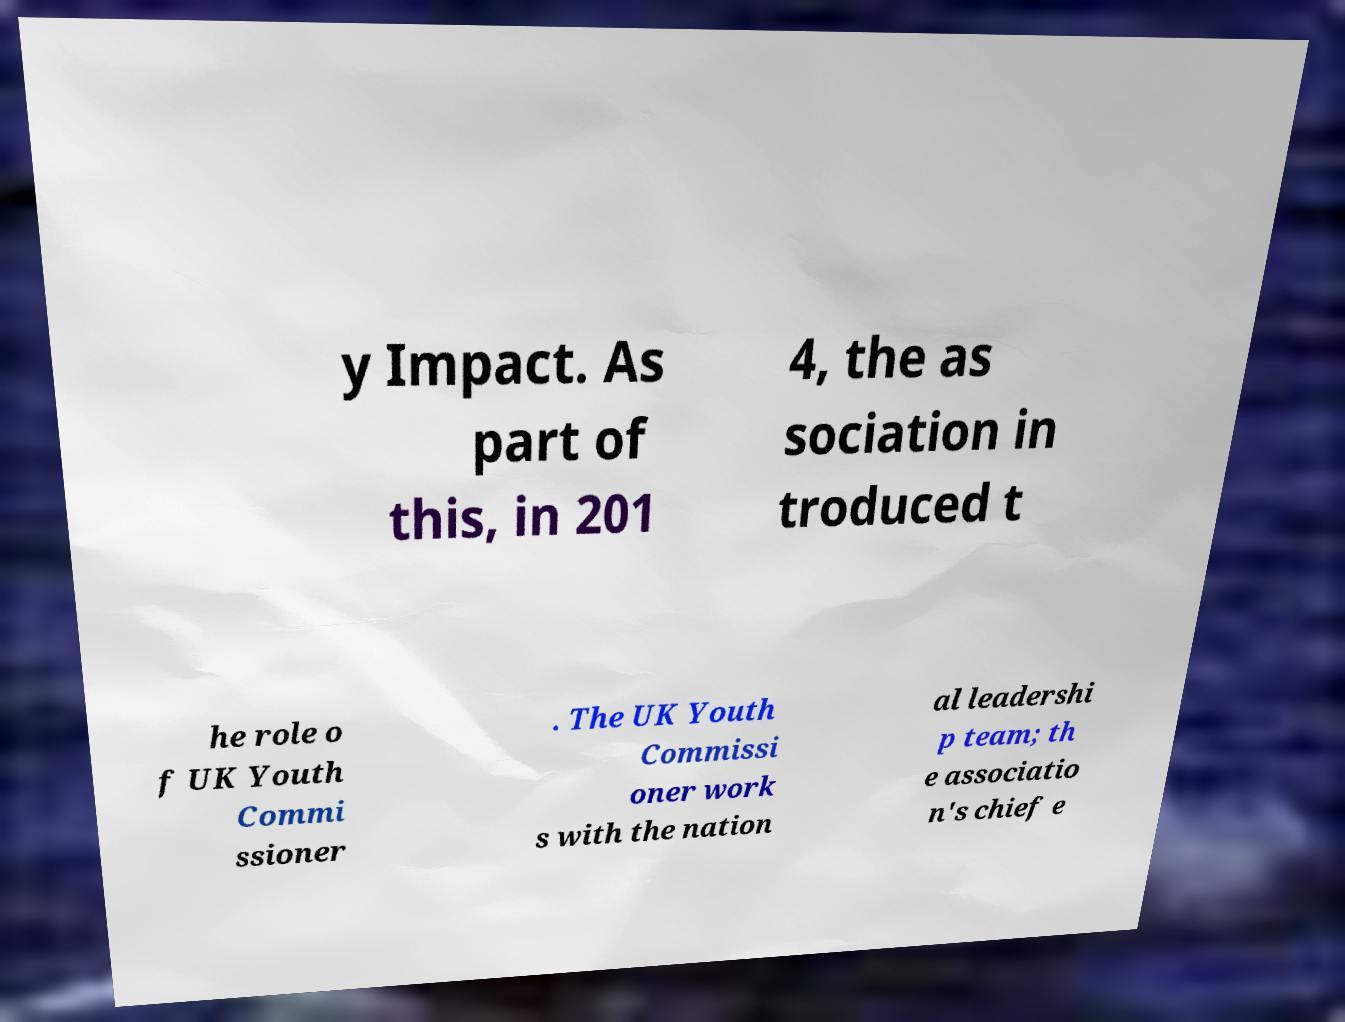Can you accurately transcribe the text from the provided image for me? y Impact. As part of this, in 201 4, the as sociation in troduced t he role o f UK Youth Commi ssioner . The UK Youth Commissi oner work s with the nation al leadershi p team; th e associatio n's chief e 